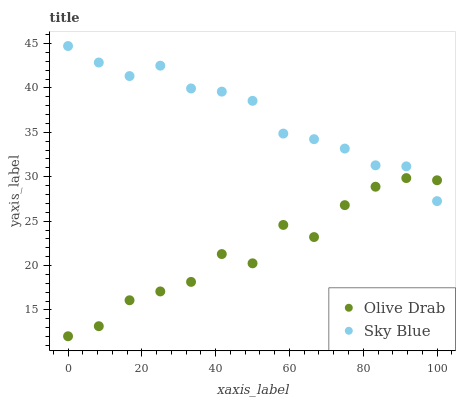Does Olive Drab have the minimum area under the curve?
Answer yes or no. Yes. Does Sky Blue have the maximum area under the curve?
Answer yes or no. Yes. Does Olive Drab have the maximum area under the curve?
Answer yes or no. No. Is Sky Blue the smoothest?
Answer yes or no. Yes. Is Olive Drab the roughest?
Answer yes or no. Yes. Is Olive Drab the smoothest?
Answer yes or no. No. Does Olive Drab have the lowest value?
Answer yes or no. Yes. Does Sky Blue have the highest value?
Answer yes or no. Yes. Does Olive Drab have the highest value?
Answer yes or no. No. Does Olive Drab intersect Sky Blue?
Answer yes or no. Yes. Is Olive Drab less than Sky Blue?
Answer yes or no. No. Is Olive Drab greater than Sky Blue?
Answer yes or no. No. 